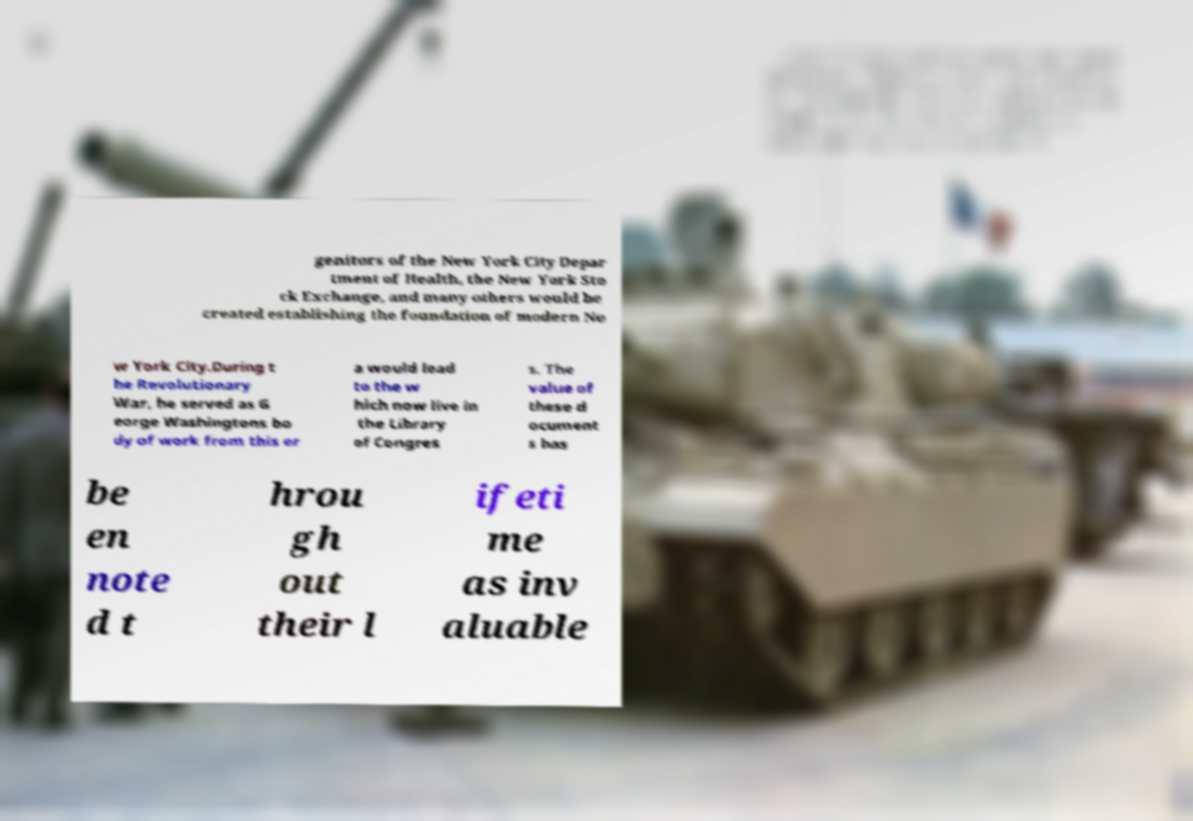Could you assist in decoding the text presented in this image and type it out clearly? genitors of the New York City Depar tment of Health, the New York Sto ck Exchange, and many others would be created establishing the foundation of modern Ne w York City.During t he Revolutionary War, he served as G eorge Washingtons bo dy of work from this er a would lead to the w hich now live in the Library of Congres s. The value of these d ocument s has be en note d t hrou gh out their l ifeti me as inv aluable 